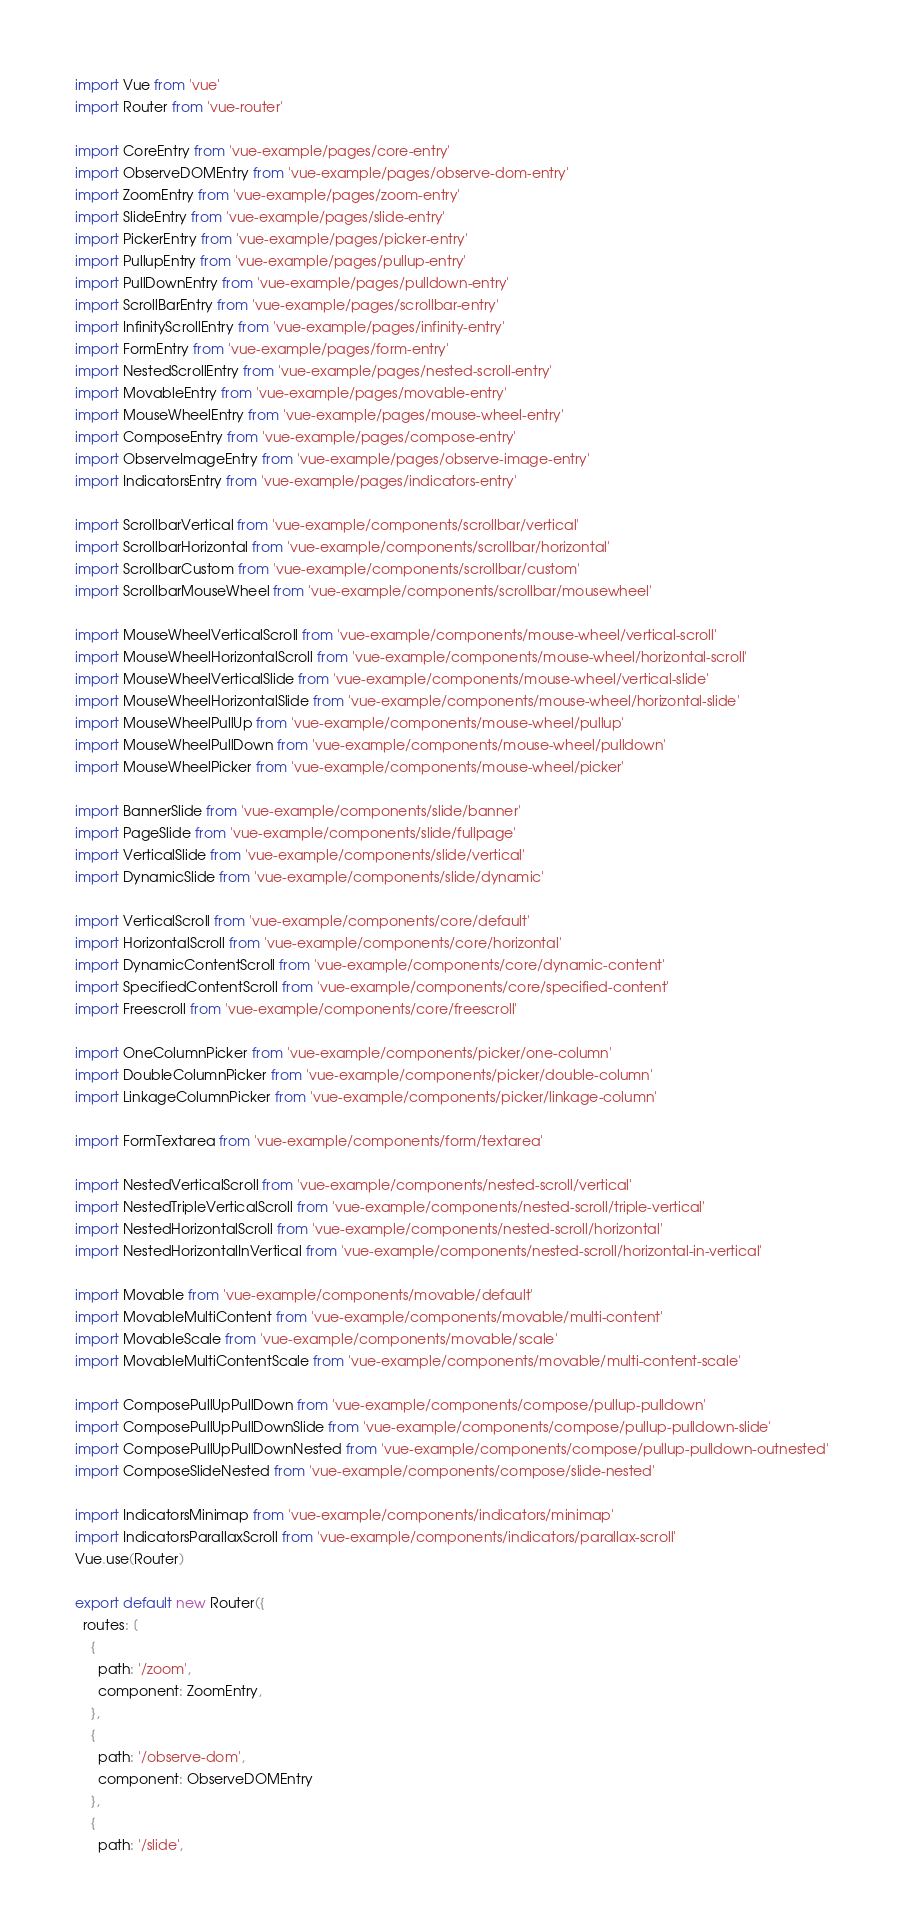Convert code to text. <code><loc_0><loc_0><loc_500><loc_500><_JavaScript_>import Vue from 'vue'
import Router from 'vue-router'

import CoreEntry from 'vue-example/pages/core-entry'
import ObserveDOMEntry from 'vue-example/pages/observe-dom-entry'
import ZoomEntry from 'vue-example/pages/zoom-entry'
import SlideEntry from 'vue-example/pages/slide-entry'
import PickerEntry from 'vue-example/pages/picker-entry'
import PullupEntry from 'vue-example/pages/pullup-entry'
import PullDownEntry from 'vue-example/pages/pulldown-entry'
import ScrollBarEntry from 'vue-example/pages/scrollbar-entry'
import InfinityScrollEntry from 'vue-example/pages/infinity-entry'
import FormEntry from 'vue-example/pages/form-entry'
import NestedScrollEntry from 'vue-example/pages/nested-scroll-entry'
import MovableEntry from 'vue-example/pages/movable-entry'
import MouseWheelEntry from 'vue-example/pages/mouse-wheel-entry'
import ComposeEntry from 'vue-example/pages/compose-entry'
import ObserveImageEntry from 'vue-example/pages/observe-image-entry'
import IndicatorsEntry from 'vue-example/pages/indicators-entry'

import ScrollbarVertical from 'vue-example/components/scrollbar/vertical'
import ScrollbarHorizontal from 'vue-example/components/scrollbar/horizontal'
import ScrollbarCustom from 'vue-example/components/scrollbar/custom'
import ScrollbarMouseWheel from 'vue-example/components/scrollbar/mousewheel'

import MouseWheelVerticalScroll from 'vue-example/components/mouse-wheel/vertical-scroll'
import MouseWheelHorizontalScroll from 'vue-example/components/mouse-wheel/horizontal-scroll'
import MouseWheelVerticalSlide from 'vue-example/components/mouse-wheel/vertical-slide'
import MouseWheelHorizontalSlide from 'vue-example/components/mouse-wheel/horizontal-slide'
import MouseWheelPullUp from 'vue-example/components/mouse-wheel/pullup'
import MouseWheelPullDown from 'vue-example/components/mouse-wheel/pulldown'
import MouseWheelPicker from 'vue-example/components/mouse-wheel/picker'

import BannerSlide from 'vue-example/components/slide/banner'
import PageSlide from 'vue-example/components/slide/fullpage'
import VerticalSlide from 'vue-example/components/slide/vertical'
import DynamicSlide from 'vue-example/components/slide/dynamic'

import VerticalScroll from 'vue-example/components/core/default'
import HorizontalScroll from 'vue-example/components/core/horizontal'
import DynamicContentScroll from 'vue-example/components/core/dynamic-content'
import SpecifiedContentScroll from 'vue-example/components/core/specified-content'
import Freescroll from 'vue-example/components/core/freescroll'

import OneColumnPicker from 'vue-example/components/picker/one-column'
import DoubleColumnPicker from 'vue-example/components/picker/double-column'
import LinkageColumnPicker from 'vue-example/components/picker/linkage-column'

import FormTextarea from 'vue-example/components/form/textarea'

import NestedVerticalScroll from 'vue-example/components/nested-scroll/vertical'
import NestedTripleVerticalScroll from 'vue-example/components/nested-scroll/triple-vertical'
import NestedHorizontalScroll from 'vue-example/components/nested-scroll/horizontal'
import NestedHorizontalInVertical from 'vue-example/components/nested-scroll/horizontal-in-vertical'

import Movable from 'vue-example/components/movable/default'
import MovableMultiContent from 'vue-example/components/movable/multi-content'
import MovableScale from 'vue-example/components/movable/scale'
import MovableMultiContentScale from 'vue-example/components/movable/multi-content-scale'

import ComposePullUpPullDown from 'vue-example/components/compose/pullup-pulldown'
import ComposePullUpPullDownSlide from 'vue-example/components/compose/pullup-pulldown-slide'
import ComposePullUpPullDownNested from 'vue-example/components/compose/pullup-pulldown-outnested'
import ComposeSlideNested from 'vue-example/components/compose/slide-nested'

import IndicatorsMinimap from 'vue-example/components/indicators/minimap'
import IndicatorsParallaxScroll from 'vue-example/components/indicators/parallax-scroll'
Vue.use(Router)

export default new Router({
  routes: [
    {
      path: '/zoom',
      component: ZoomEntry,
    },
    {
      path: '/observe-dom',
      component: ObserveDOMEntry
    },
    {
      path: '/slide',</code> 